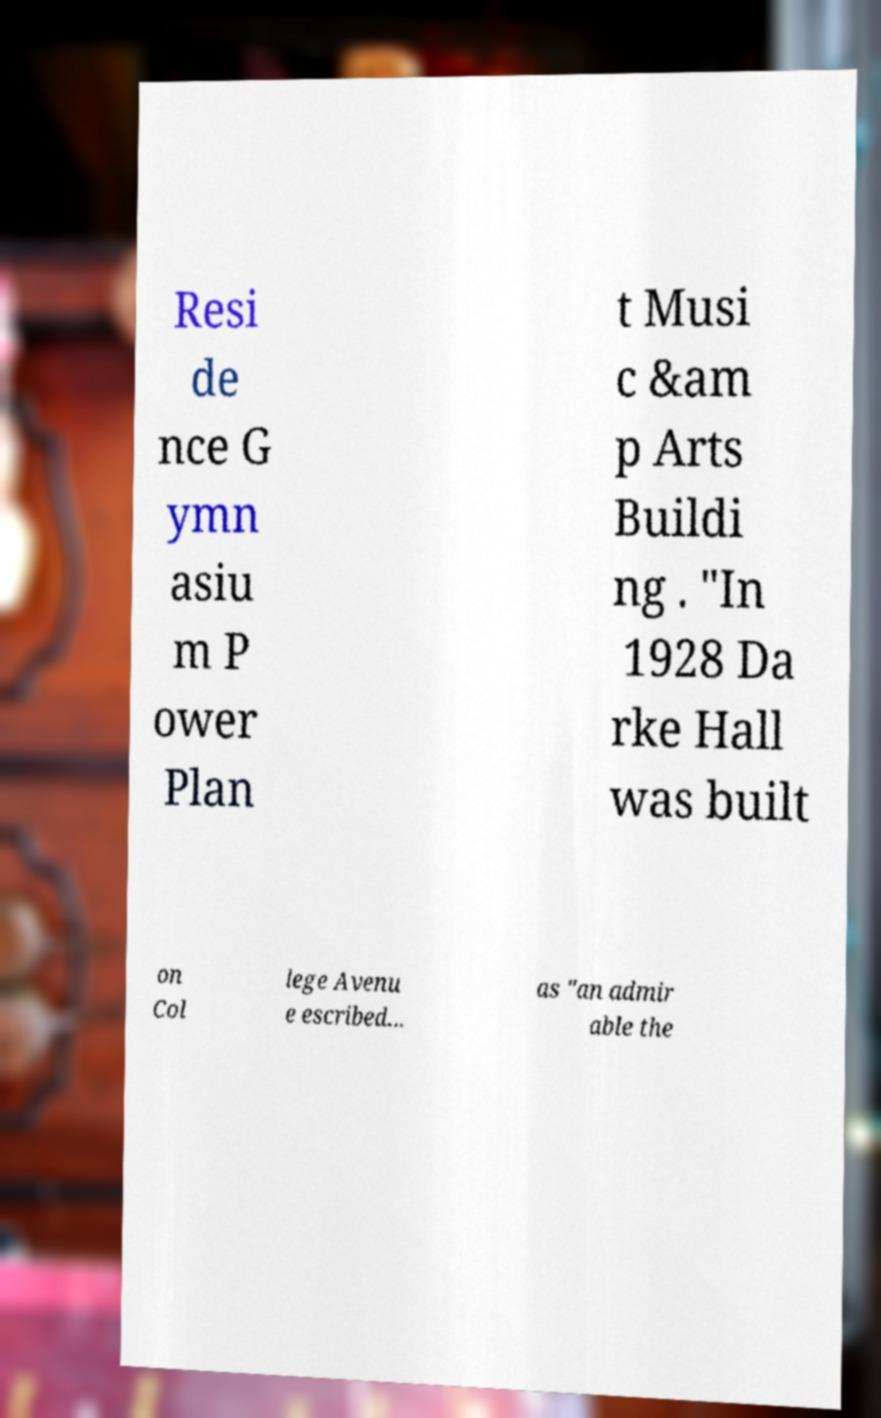Please read and relay the text visible in this image. What does it say? Resi de nce G ymn asiu m P ower Plan t Musi c &am p Arts Buildi ng . "In 1928 Da rke Hall was built on Col lege Avenu e escribed... as "an admir able the 